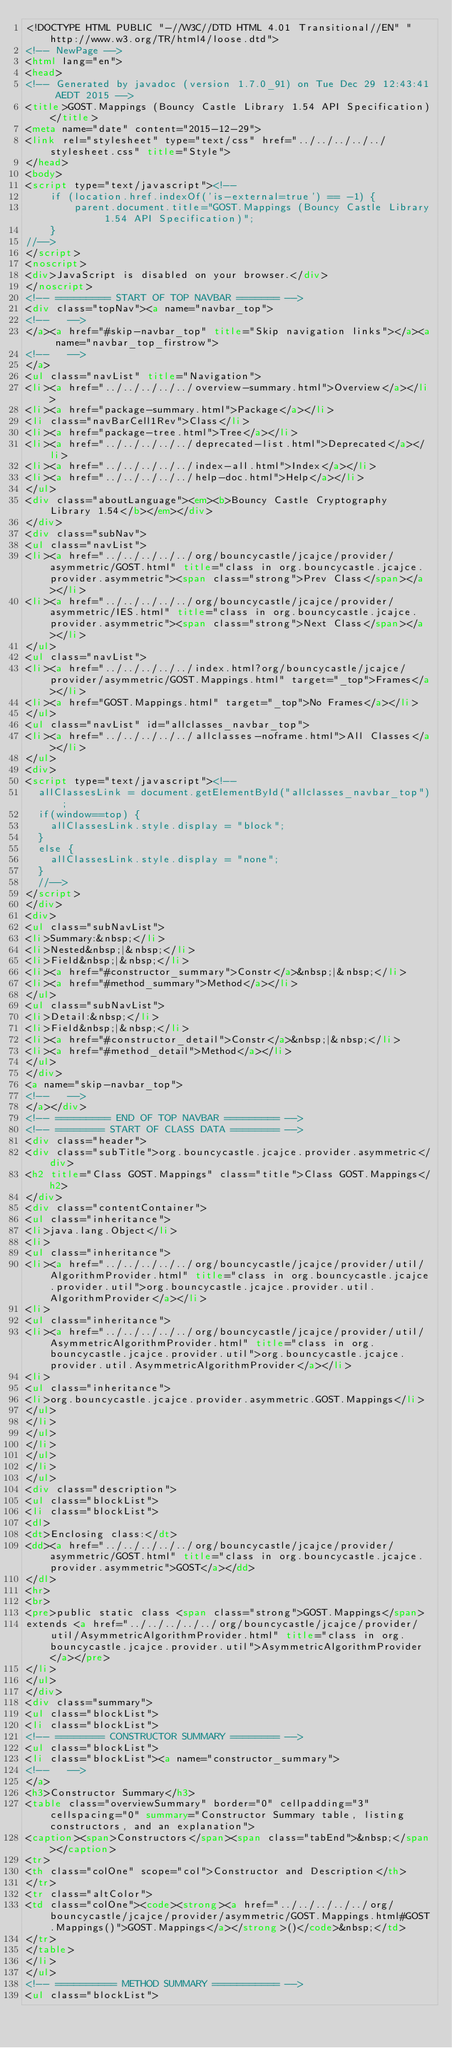Convert code to text. <code><loc_0><loc_0><loc_500><loc_500><_HTML_><!DOCTYPE HTML PUBLIC "-//W3C//DTD HTML 4.01 Transitional//EN" "http://www.w3.org/TR/html4/loose.dtd">
<!-- NewPage -->
<html lang="en">
<head>
<!-- Generated by javadoc (version 1.7.0_91) on Tue Dec 29 12:43:41 AEDT 2015 -->
<title>GOST.Mappings (Bouncy Castle Library 1.54 API Specification)</title>
<meta name="date" content="2015-12-29">
<link rel="stylesheet" type="text/css" href="../../../../../stylesheet.css" title="Style">
</head>
<body>
<script type="text/javascript"><!--
    if (location.href.indexOf('is-external=true') == -1) {
        parent.document.title="GOST.Mappings (Bouncy Castle Library 1.54 API Specification)";
    }
//-->
</script>
<noscript>
<div>JavaScript is disabled on your browser.</div>
</noscript>
<!-- ========= START OF TOP NAVBAR ======= -->
<div class="topNav"><a name="navbar_top">
<!--   -->
</a><a href="#skip-navbar_top" title="Skip navigation links"></a><a name="navbar_top_firstrow">
<!--   -->
</a>
<ul class="navList" title="Navigation">
<li><a href="../../../../../overview-summary.html">Overview</a></li>
<li><a href="package-summary.html">Package</a></li>
<li class="navBarCell1Rev">Class</li>
<li><a href="package-tree.html">Tree</a></li>
<li><a href="../../../../../deprecated-list.html">Deprecated</a></li>
<li><a href="../../../../../index-all.html">Index</a></li>
<li><a href="../../../../../help-doc.html">Help</a></li>
</ul>
<div class="aboutLanguage"><em><b>Bouncy Castle Cryptography Library 1.54</b></em></div>
</div>
<div class="subNav">
<ul class="navList">
<li><a href="../../../../../org/bouncycastle/jcajce/provider/asymmetric/GOST.html" title="class in org.bouncycastle.jcajce.provider.asymmetric"><span class="strong">Prev Class</span></a></li>
<li><a href="../../../../../org/bouncycastle/jcajce/provider/asymmetric/IES.html" title="class in org.bouncycastle.jcajce.provider.asymmetric"><span class="strong">Next Class</span></a></li>
</ul>
<ul class="navList">
<li><a href="../../../../../index.html?org/bouncycastle/jcajce/provider/asymmetric/GOST.Mappings.html" target="_top">Frames</a></li>
<li><a href="GOST.Mappings.html" target="_top">No Frames</a></li>
</ul>
<ul class="navList" id="allclasses_navbar_top">
<li><a href="../../../../../allclasses-noframe.html">All Classes</a></li>
</ul>
<div>
<script type="text/javascript"><!--
  allClassesLink = document.getElementById("allclasses_navbar_top");
  if(window==top) {
    allClassesLink.style.display = "block";
  }
  else {
    allClassesLink.style.display = "none";
  }
  //-->
</script>
</div>
<div>
<ul class="subNavList">
<li>Summary:&nbsp;</li>
<li>Nested&nbsp;|&nbsp;</li>
<li>Field&nbsp;|&nbsp;</li>
<li><a href="#constructor_summary">Constr</a>&nbsp;|&nbsp;</li>
<li><a href="#method_summary">Method</a></li>
</ul>
<ul class="subNavList">
<li>Detail:&nbsp;</li>
<li>Field&nbsp;|&nbsp;</li>
<li><a href="#constructor_detail">Constr</a>&nbsp;|&nbsp;</li>
<li><a href="#method_detail">Method</a></li>
</ul>
</div>
<a name="skip-navbar_top">
<!--   -->
</a></div>
<!-- ========= END OF TOP NAVBAR ========= -->
<!-- ======== START OF CLASS DATA ======== -->
<div class="header">
<div class="subTitle">org.bouncycastle.jcajce.provider.asymmetric</div>
<h2 title="Class GOST.Mappings" class="title">Class GOST.Mappings</h2>
</div>
<div class="contentContainer">
<ul class="inheritance">
<li>java.lang.Object</li>
<li>
<ul class="inheritance">
<li><a href="../../../../../org/bouncycastle/jcajce/provider/util/AlgorithmProvider.html" title="class in org.bouncycastle.jcajce.provider.util">org.bouncycastle.jcajce.provider.util.AlgorithmProvider</a></li>
<li>
<ul class="inheritance">
<li><a href="../../../../../org/bouncycastle/jcajce/provider/util/AsymmetricAlgorithmProvider.html" title="class in org.bouncycastle.jcajce.provider.util">org.bouncycastle.jcajce.provider.util.AsymmetricAlgorithmProvider</a></li>
<li>
<ul class="inheritance">
<li>org.bouncycastle.jcajce.provider.asymmetric.GOST.Mappings</li>
</ul>
</li>
</ul>
</li>
</ul>
</li>
</ul>
<div class="description">
<ul class="blockList">
<li class="blockList">
<dl>
<dt>Enclosing class:</dt>
<dd><a href="../../../../../org/bouncycastle/jcajce/provider/asymmetric/GOST.html" title="class in org.bouncycastle.jcajce.provider.asymmetric">GOST</a></dd>
</dl>
<hr>
<br>
<pre>public static class <span class="strong">GOST.Mappings</span>
extends <a href="../../../../../org/bouncycastle/jcajce/provider/util/AsymmetricAlgorithmProvider.html" title="class in org.bouncycastle.jcajce.provider.util">AsymmetricAlgorithmProvider</a></pre>
</li>
</ul>
</div>
<div class="summary">
<ul class="blockList">
<li class="blockList">
<!-- ======== CONSTRUCTOR SUMMARY ======== -->
<ul class="blockList">
<li class="blockList"><a name="constructor_summary">
<!--   -->
</a>
<h3>Constructor Summary</h3>
<table class="overviewSummary" border="0" cellpadding="3" cellspacing="0" summary="Constructor Summary table, listing constructors, and an explanation">
<caption><span>Constructors</span><span class="tabEnd">&nbsp;</span></caption>
<tr>
<th class="colOne" scope="col">Constructor and Description</th>
</tr>
<tr class="altColor">
<td class="colOne"><code><strong><a href="../../../../../org/bouncycastle/jcajce/provider/asymmetric/GOST.Mappings.html#GOST.Mappings()">GOST.Mappings</a></strong>()</code>&nbsp;</td>
</tr>
</table>
</li>
</ul>
<!-- ========== METHOD SUMMARY =========== -->
<ul class="blockList"></code> 